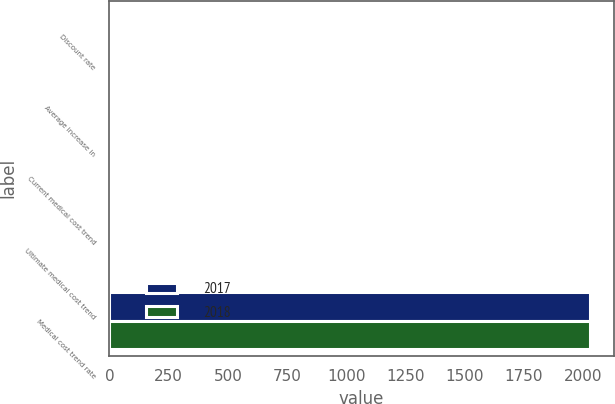<chart> <loc_0><loc_0><loc_500><loc_500><stacked_bar_chart><ecel><fcel>Discount rate<fcel>Average increase in<fcel>Current medical cost trend<fcel>Ultimate medical cost trend<fcel>Medical cost trend rate<nl><fcel>2017<fcel>4.5<fcel>3<fcel>6<fcel>4<fcel>2029<nl><fcel>2018<fcel>3.75<fcel>3<fcel>6<fcel>3.5<fcel>2029<nl></chart> 